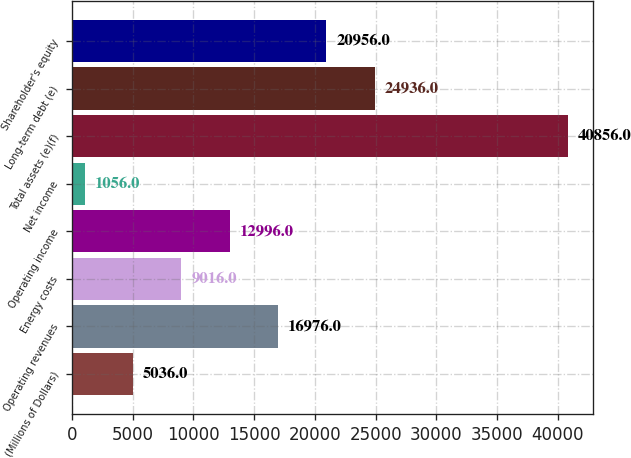<chart> <loc_0><loc_0><loc_500><loc_500><bar_chart><fcel>(Millions of Dollars)<fcel>Operating revenues<fcel>Energy costs<fcel>Operating income<fcel>Net income<fcel>Total assets (e)(f)<fcel>Long-term debt (e)<fcel>Shareholder's equity<nl><fcel>5036<fcel>16976<fcel>9016<fcel>12996<fcel>1056<fcel>40856<fcel>24936<fcel>20956<nl></chart> 